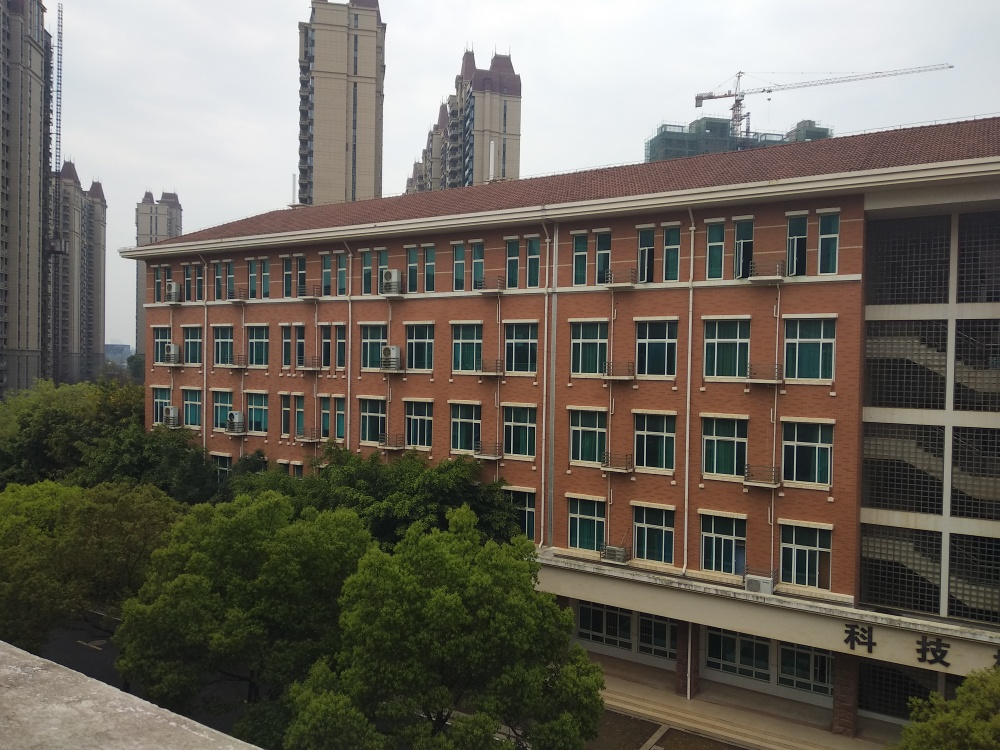Is the focus of the image accurate? Yes, the focus of the image is accurately maintained across the building's facade, allowing for clear visibility of the windows, external air conditioning units, and the texture of the brickwork. Additionally, the greenery in front of the building and the structures in the background, including the partially visible crane, are in moderate focus, providing a good sense of depth. 